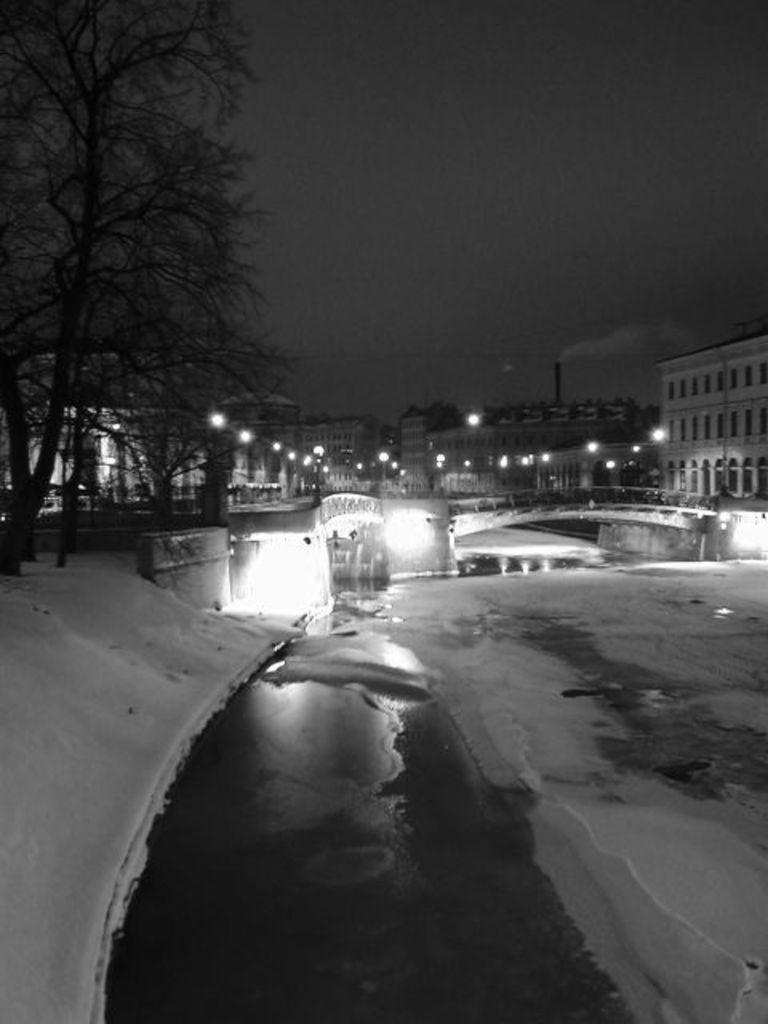In one or two sentences, can you explain what this image depicts? In this picture we can see a bridge, water and ice. In the background of the picture we can see buildings, lights and trees. At the top of the image there is the sky. 